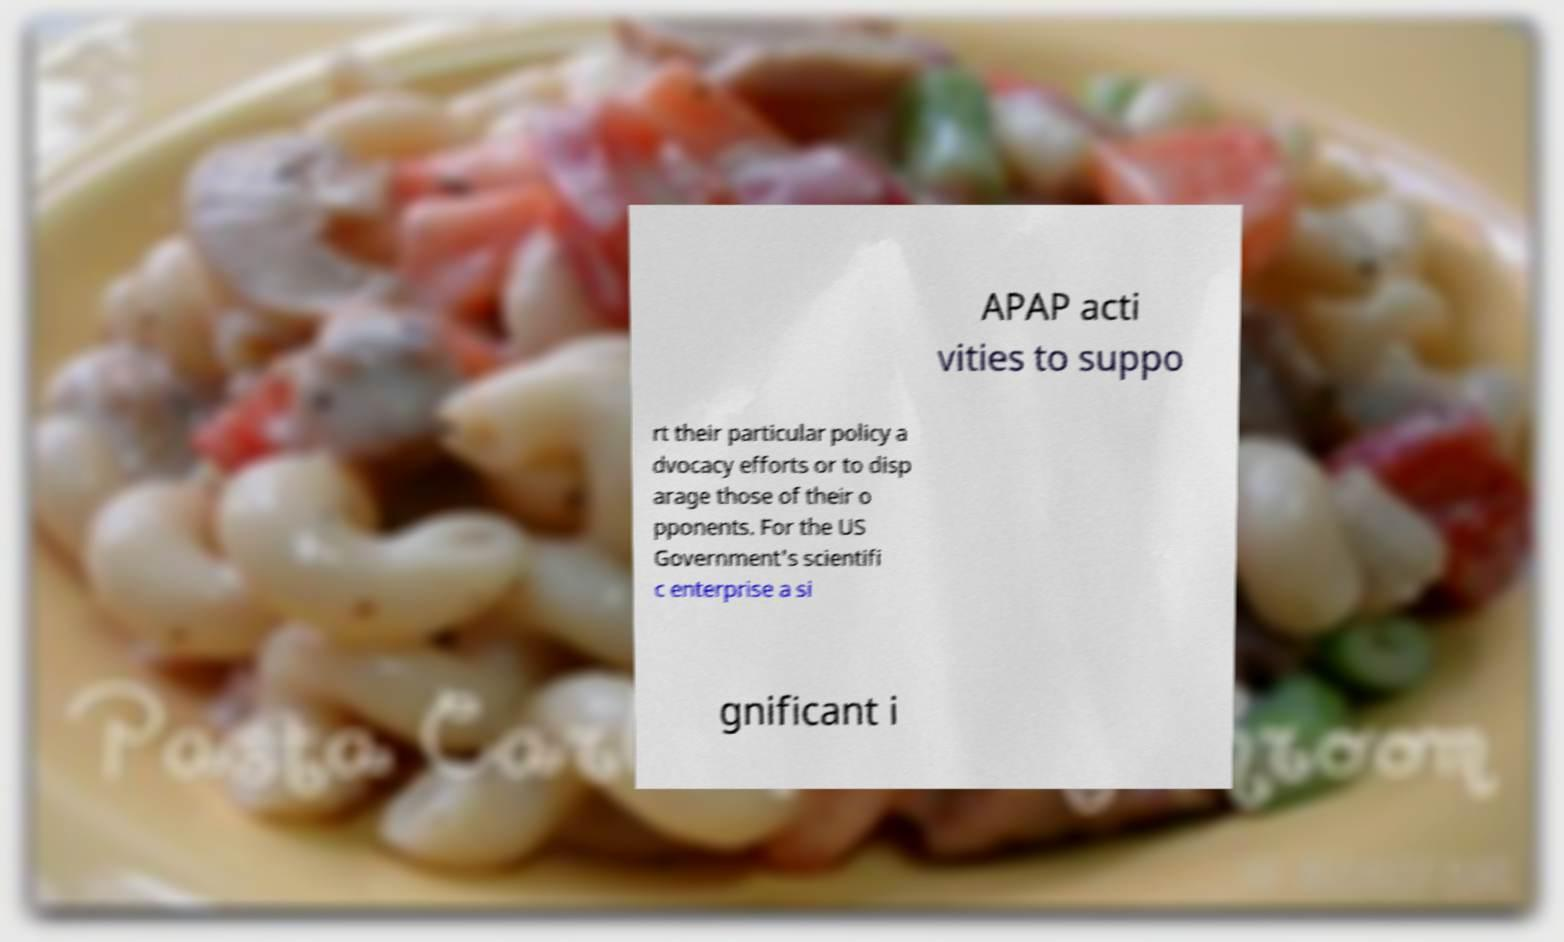Can you read and provide the text displayed in the image?This photo seems to have some interesting text. Can you extract and type it out for me? APAP acti vities to suppo rt their particular policy a dvocacy efforts or to disp arage those of their o pponents. For the US Government's scientifi c enterprise a si gnificant i 